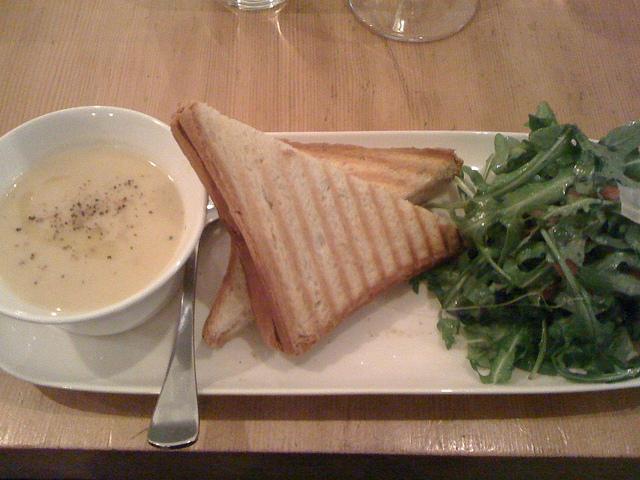Which of the objects on the plate is inedible?
Answer the question by selecting the correct answer among the 4 following choices.
Options: Soup, vegetables, bread, utensil. Utensil. 